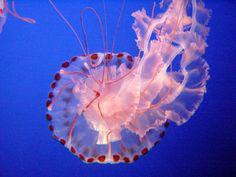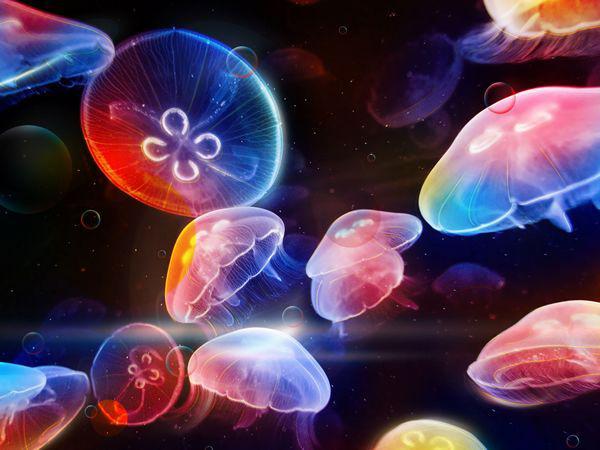The first image is the image on the left, the second image is the image on the right. Examine the images to the left and right. Is the description "The left image contains one jellyfish with a mushroom shaped cap facing rightside up and stringlike tentacles trailing down from it, and the right image includes a jellyfish with red-orange dots around the rim of its cap." accurate? Answer yes or no. No. The first image is the image on the left, the second image is the image on the right. Given the left and right images, does the statement "There are two jellyfish in one image and one in the other image." hold true? Answer yes or no. No. 